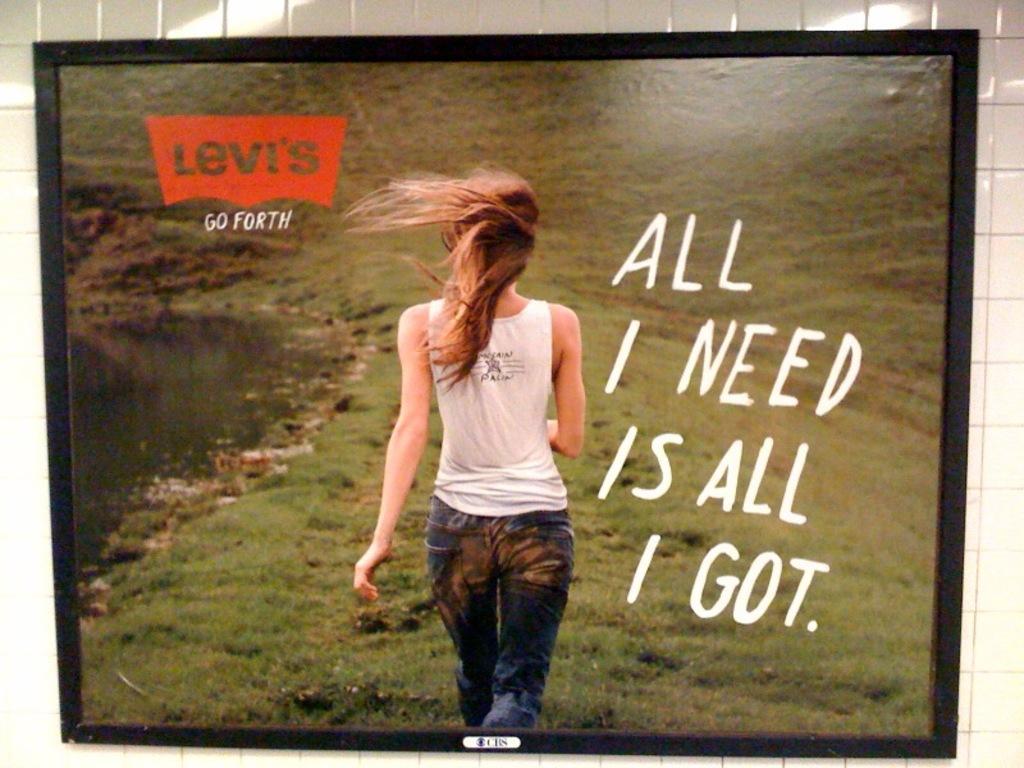Describe this image in one or two sentences. In this picture we can see frame on the wall, in this frame there is a woman walking on the grass and we can see some text and logo. 